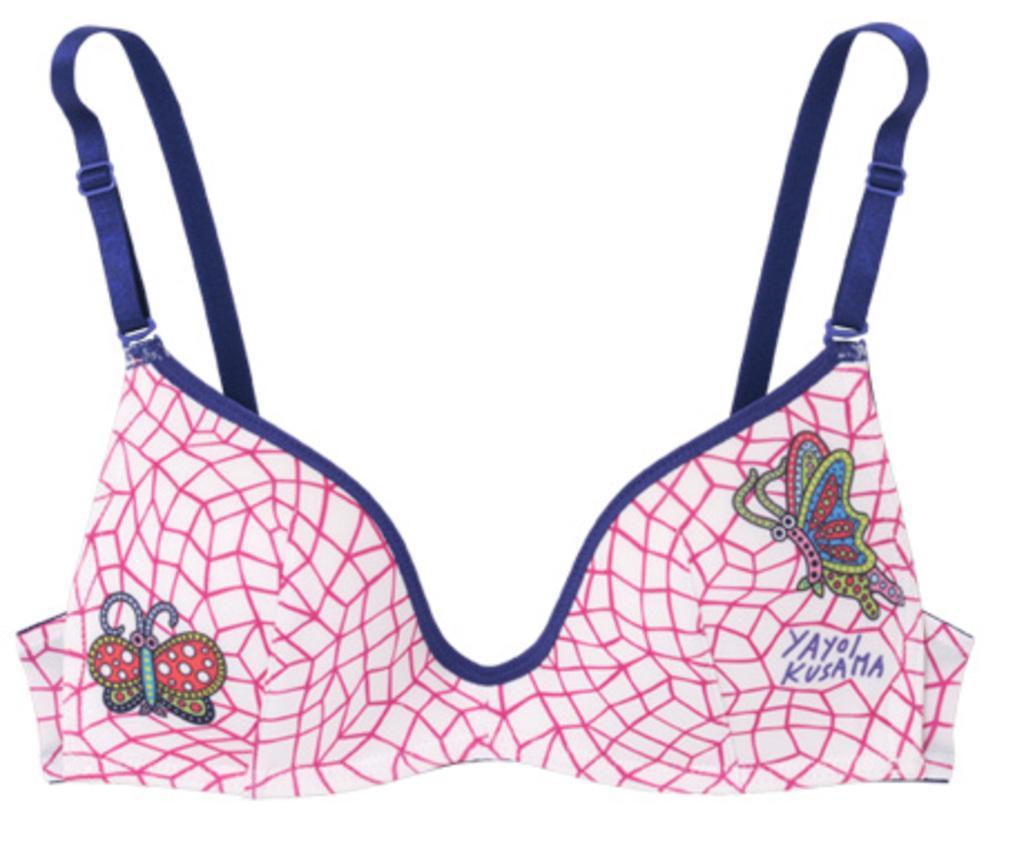Could you give a brief overview of what you see in this image? In the picture I can see clothes on which there is a design and something written on it. The background of the image is white in color. 